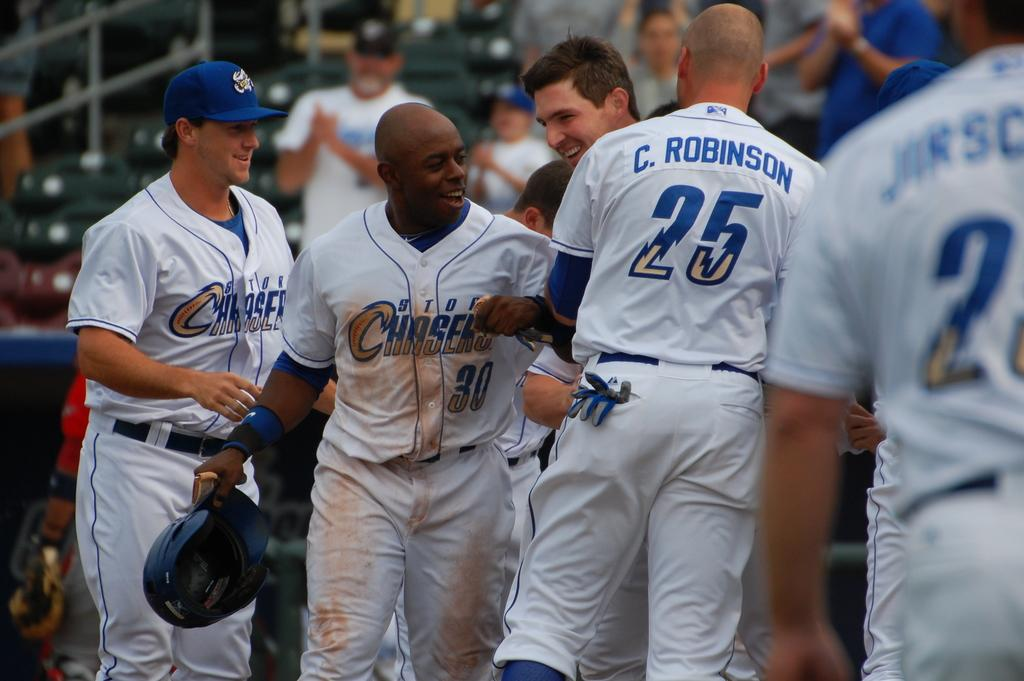<image>
Create a compact narrative representing the image presented. some players with one that wears the number 25 